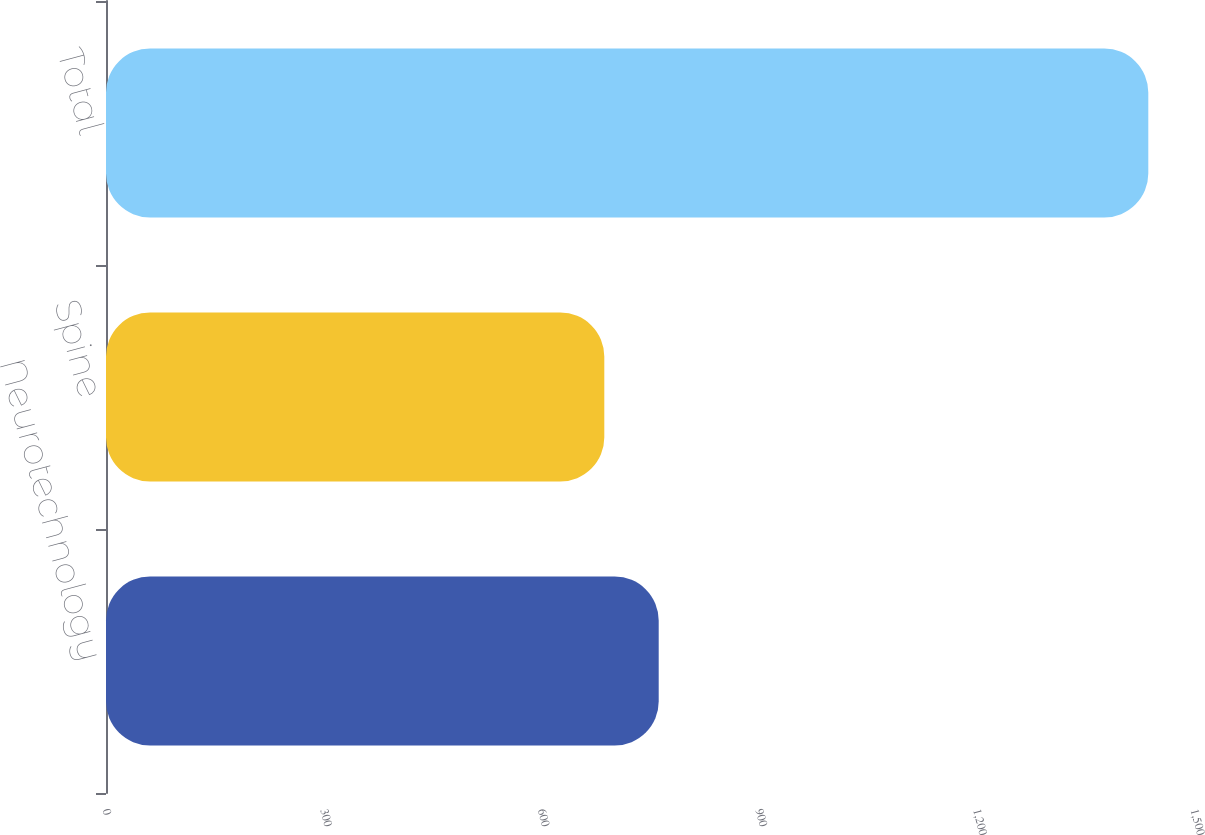Convert chart. <chart><loc_0><loc_0><loc_500><loc_500><bar_chart><fcel>Neurotechnology<fcel>Spine<fcel>Total<nl><fcel>762<fcel>687<fcel>1437<nl></chart> 